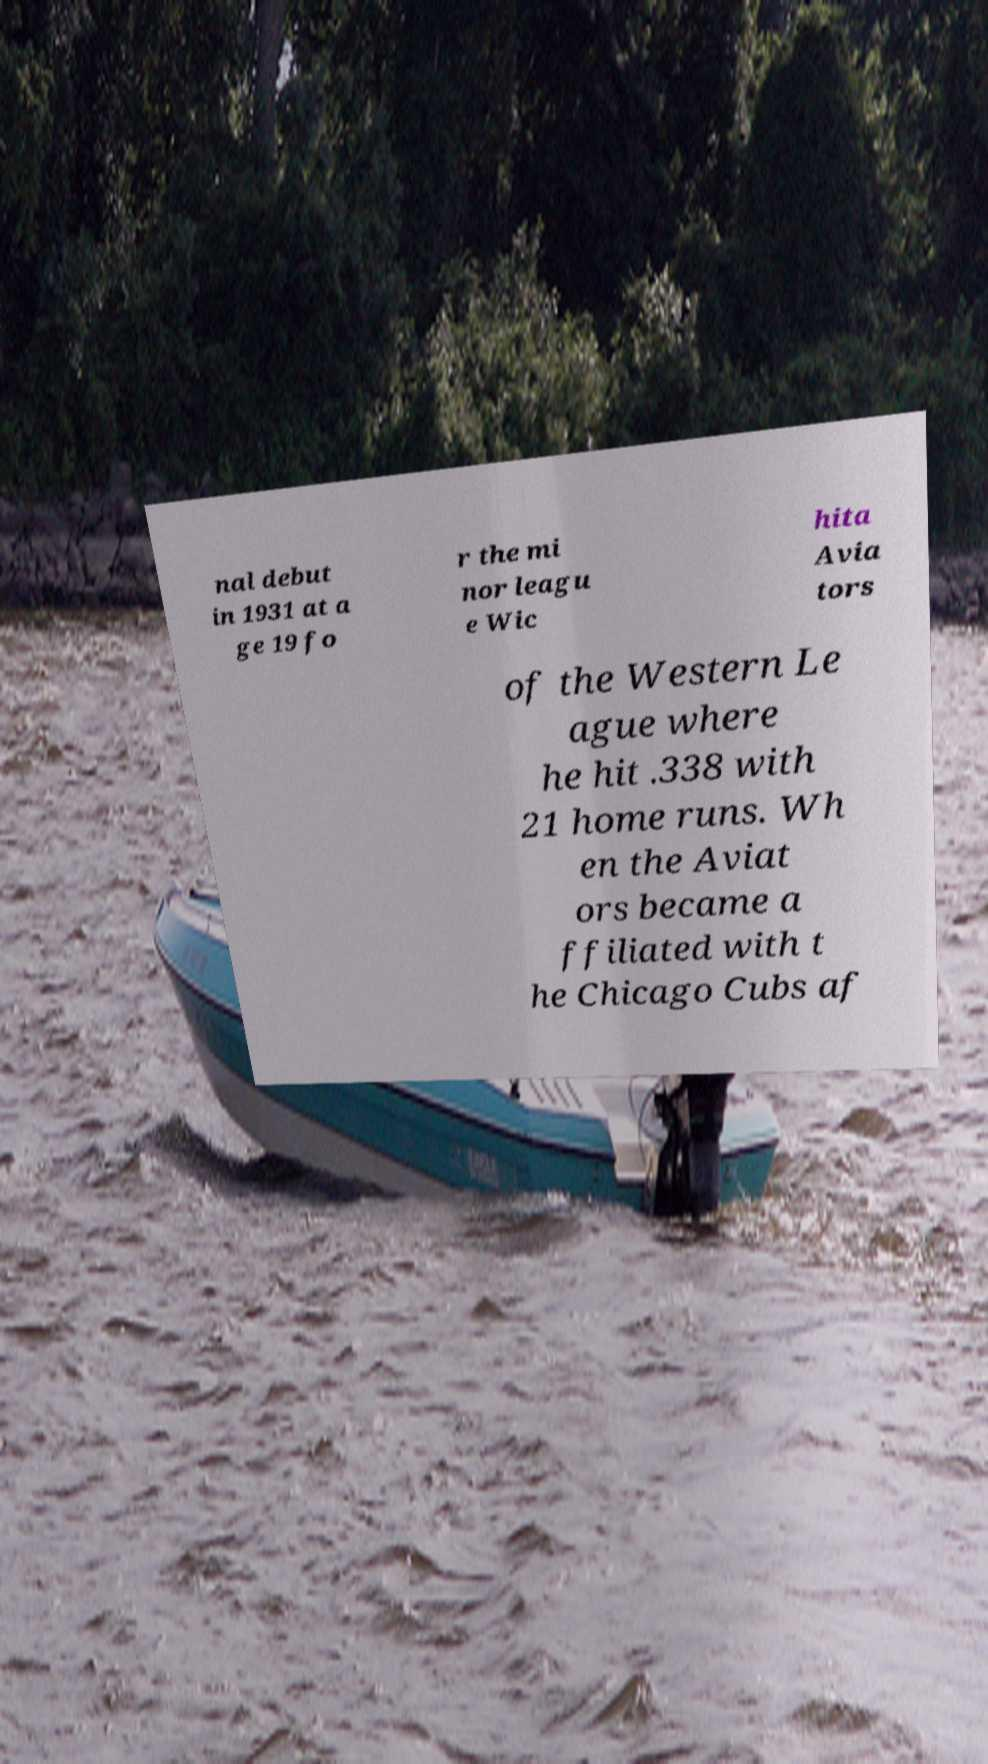For documentation purposes, I need the text within this image transcribed. Could you provide that? nal debut in 1931 at a ge 19 fo r the mi nor leagu e Wic hita Avia tors of the Western Le ague where he hit .338 with 21 home runs. Wh en the Aviat ors became a ffiliated with t he Chicago Cubs af 